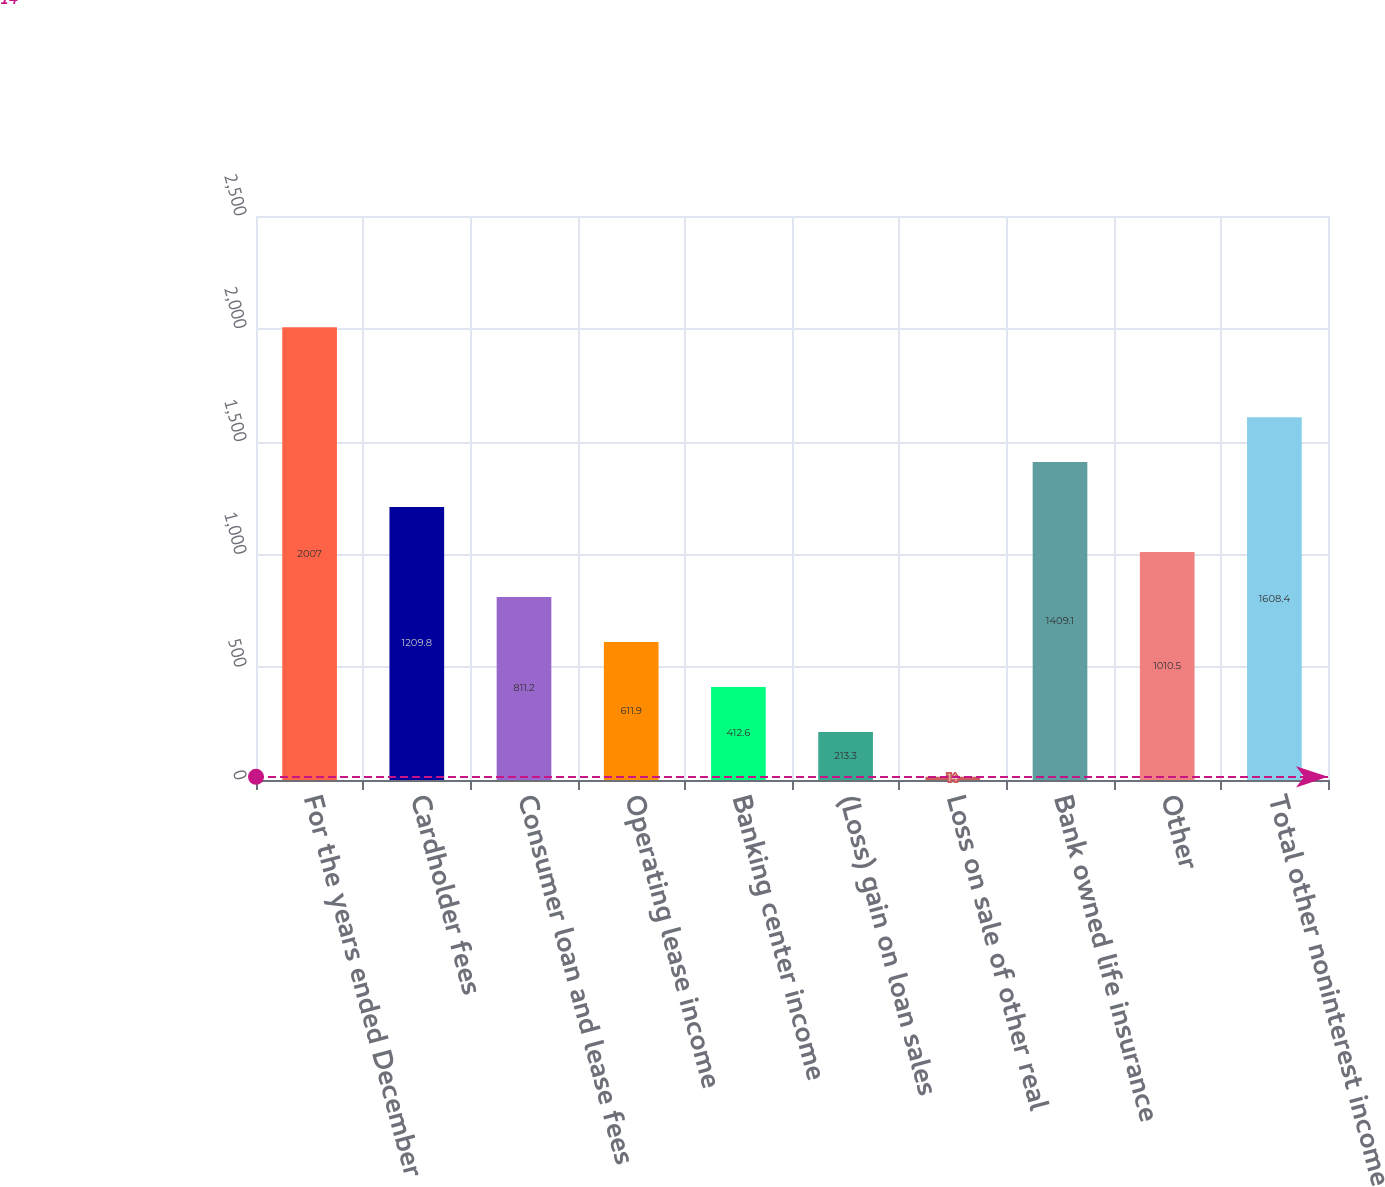Convert chart. <chart><loc_0><loc_0><loc_500><loc_500><bar_chart><fcel>For the years ended December<fcel>Cardholder fees<fcel>Consumer loan and lease fees<fcel>Operating lease income<fcel>Banking center income<fcel>(Loss) gain on loan sales<fcel>Loss on sale of other real<fcel>Bank owned life insurance<fcel>Other<fcel>Total other noninterest income<nl><fcel>2007<fcel>1209.8<fcel>811.2<fcel>611.9<fcel>412.6<fcel>213.3<fcel>14<fcel>1409.1<fcel>1010.5<fcel>1608.4<nl></chart> 